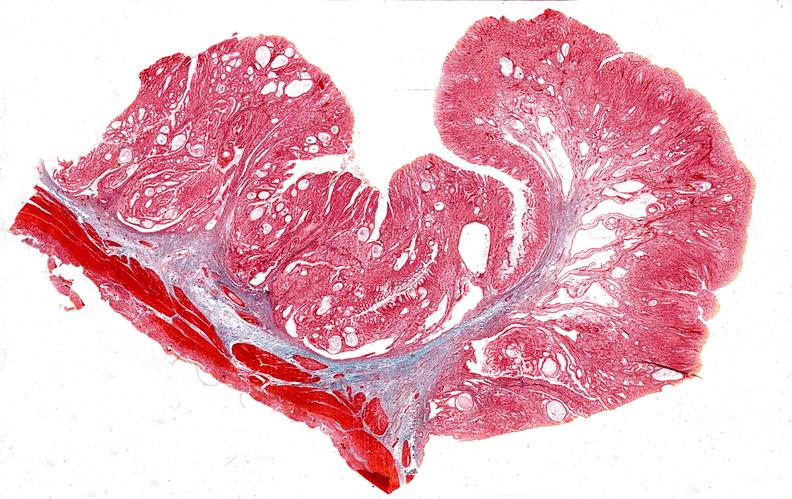does this image show stomach, giant rugose hyperplasia?
Answer the question using a single word or phrase. Yes 